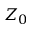<formula> <loc_0><loc_0><loc_500><loc_500>Z _ { 0 }</formula> 